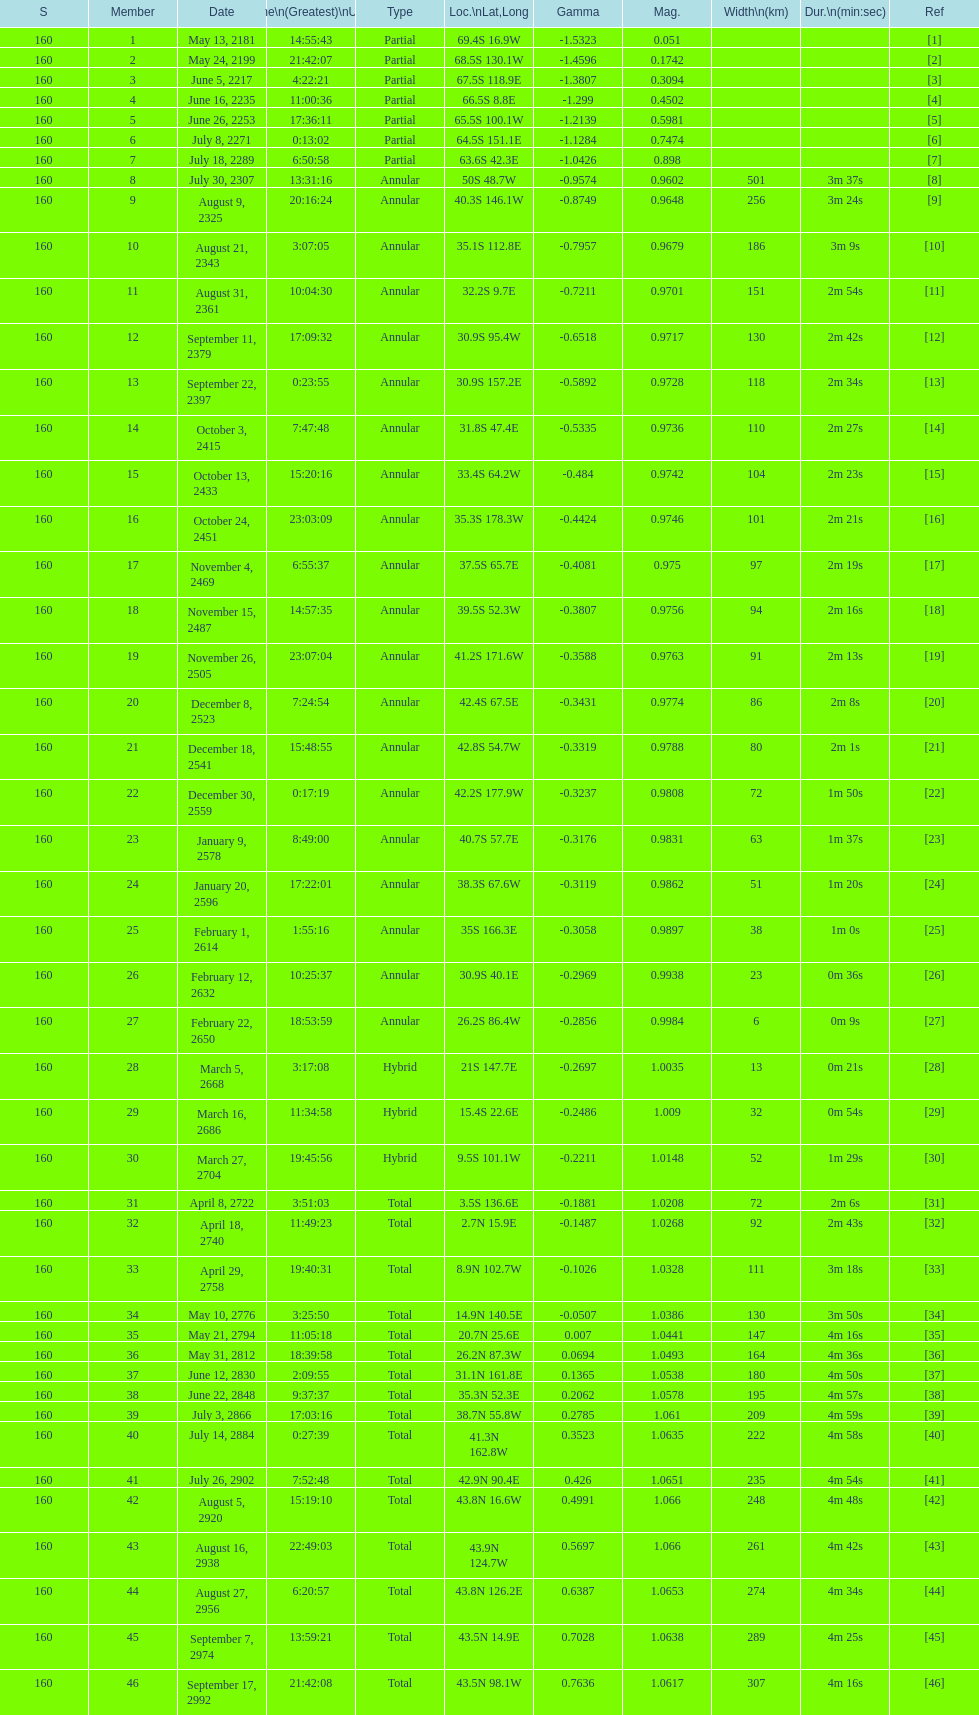Name a member number with a latitude above 60 s. 1. 